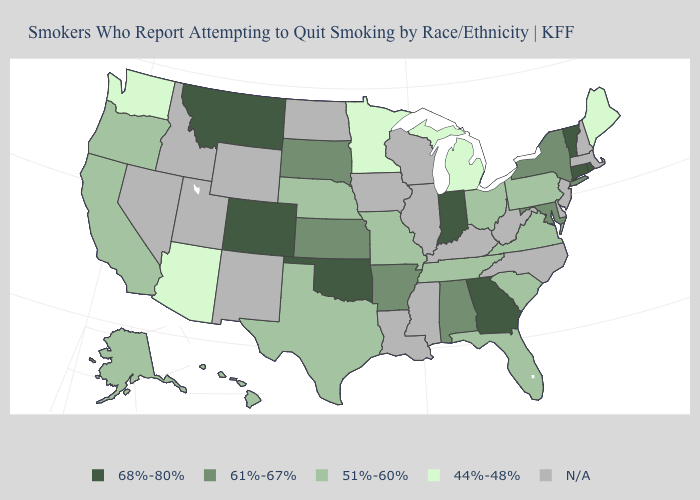Name the states that have a value in the range N/A?
Write a very short answer. Delaware, Idaho, Illinois, Iowa, Kentucky, Louisiana, Massachusetts, Mississippi, Nevada, New Hampshire, New Jersey, New Mexico, North Carolina, North Dakota, Utah, West Virginia, Wisconsin, Wyoming. Name the states that have a value in the range 61%-67%?
Answer briefly. Alabama, Arkansas, Kansas, Maryland, New York, South Dakota. What is the value of Tennessee?
Short answer required. 51%-60%. Name the states that have a value in the range 68%-80%?
Answer briefly. Colorado, Connecticut, Georgia, Indiana, Montana, Oklahoma, Rhode Island, Vermont. Does the map have missing data?
Write a very short answer. Yes. Name the states that have a value in the range 61%-67%?
Give a very brief answer. Alabama, Arkansas, Kansas, Maryland, New York, South Dakota. Name the states that have a value in the range 68%-80%?
Quick response, please. Colorado, Connecticut, Georgia, Indiana, Montana, Oklahoma, Rhode Island, Vermont. Does Connecticut have the highest value in the Northeast?
Quick response, please. Yes. Does Vermont have the lowest value in the USA?
Short answer required. No. Among the states that border Arkansas , which have the lowest value?
Write a very short answer. Missouri, Tennessee, Texas. What is the value of South Dakota?
Quick response, please. 61%-67%. Is the legend a continuous bar?
Quick response, please. No. What is the value of North Dakota?
Short answer required. N/A. Among the states that border Illinois , which have the lowest value?
Be succinct. Missouri. What is the value of Massachusetts?
Write a very short answer. N/A. 